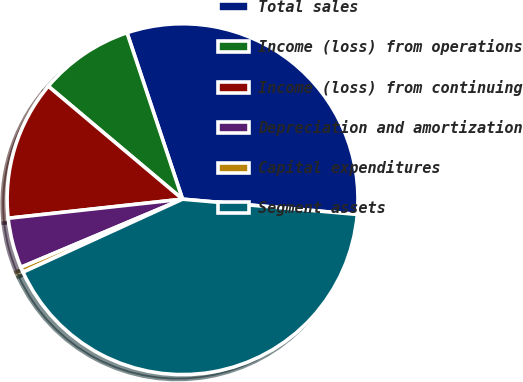Convert chart to OTSL. <chart><loc_0><loc_0><loc_500><loc_500><pie_chart><fcel>Total sales<fcel>Income (loss) from operations<fcel>Income (loss) from continuing<fcel>Depreciation and amortization<fcel>Capital expenditures<fcel>Segment assets<nl><fcel>31.51%<fcel>8.74%<fcel>12.87%<fcel>4.61%<fcel>0.48%<fcel>41.78%<nl></chart> 